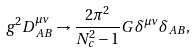<formula> <loc_0><loc_0><loc_500><loc_500>g ^ { 2 } D ^ { \mu \nu } _ { A B } \rightarrow \frac { 2 \pi ^ { 2 } } { N _ { c } ^ { 2 } - 1 } G \, \delta ^ { \mu \nu } \delta _ { A B } ,</formula> 